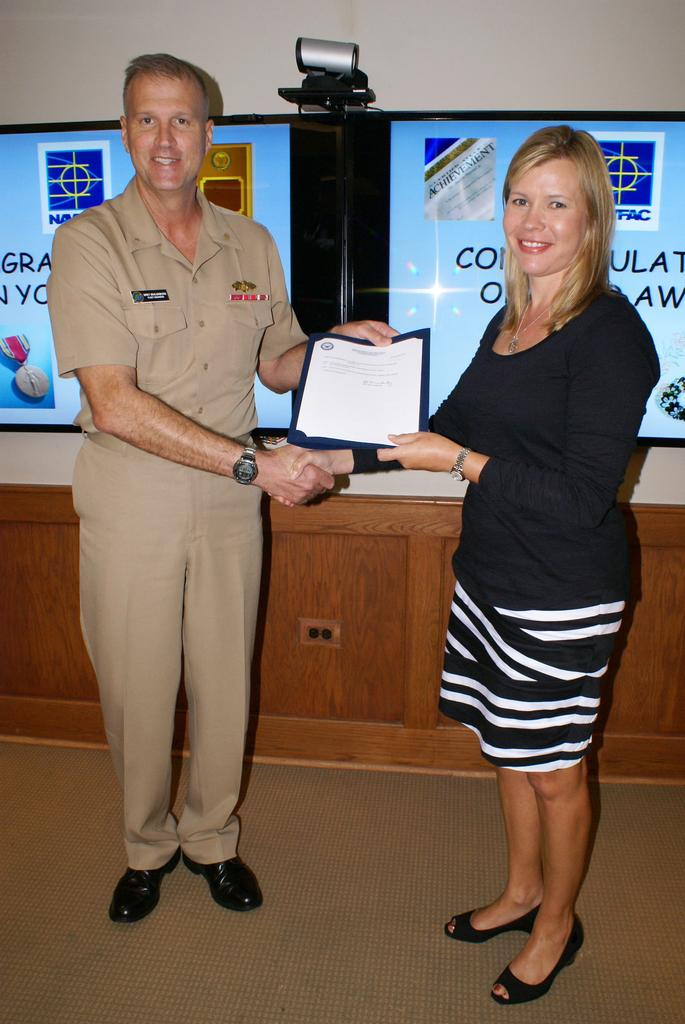How many people are present in the image? There is a man and a woman present in the image. What is the woman holding in the image? The woman is holding a certificate. What can be seen in the background of the image? There are boards, an object, and a wall visible in the background. Is the committee meeting taking place in the quicksand in the image? There is no quicksand or committee meeting present in the image. What type of flag is being waved by the woman in the image? There is no flag visible in the image; the woman is holding a certificate. 